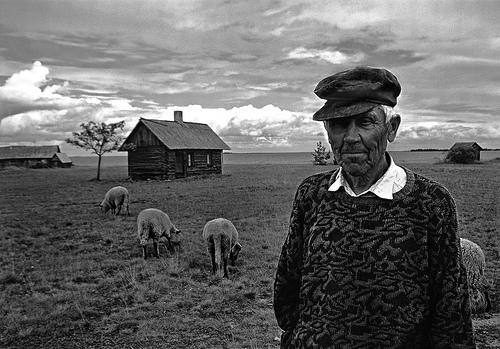What color is the shirt underneath of the old man's sweater? Please explain your reasoning. white. That is the color of the shirt. 